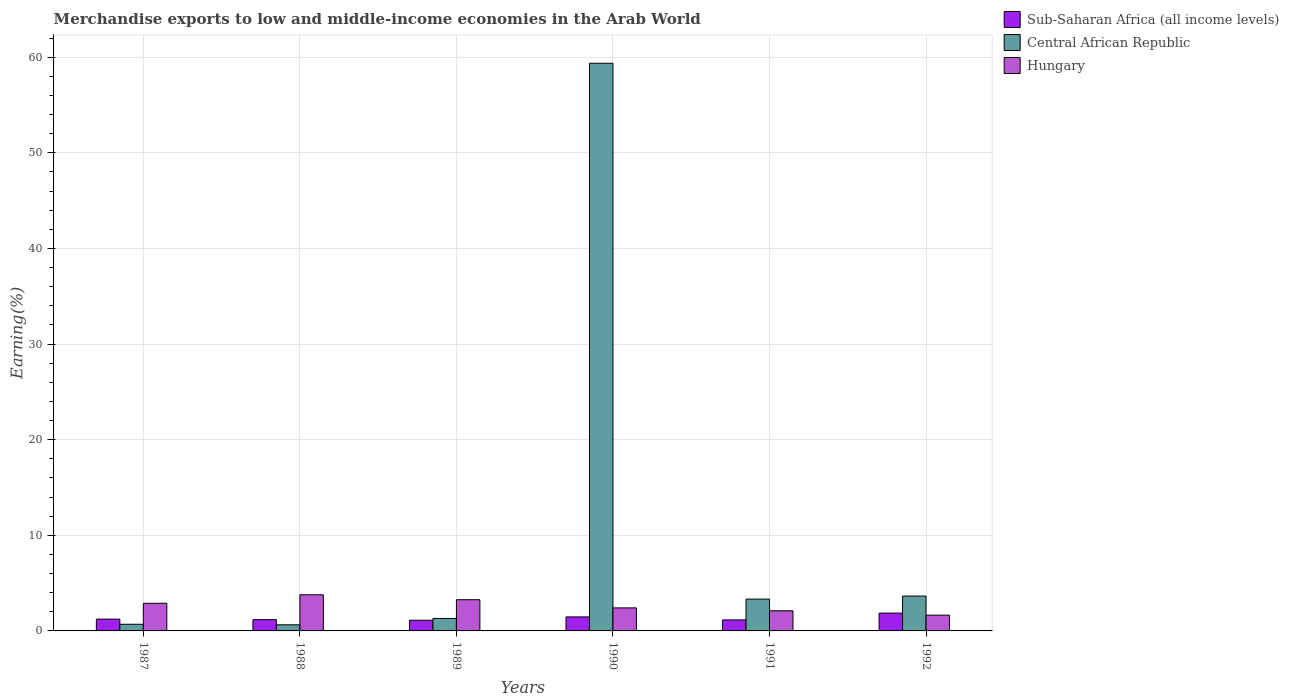How many different coloured bars are there?
Offer a terse response. 3. How many groups of bars are there?
Offer a very short reply. 6. How many bars are there on the 4th tick from the left?
Keep it short and to the point. 3. What is the percentage of amount earned from merchandise exports in Hungary in 1988?
Give a very brief answer. 3.78. Across all years, what is the maximum percentage of amount earned from merchandise exports in Central African Republic?
Your answer should be compact. 59.37. Across all years, what is the minimum percentage of amount earned from merchandise exports in Hungary?
Offer a very short reply. 1.65. In which year was the percentage of amount earned from merchandise exports in Hungary maximum?
Offer a terse response. 1988. What is the total percentage of amount earned from merchandise exports in Hungary in the graph?
Provide a succinct answer. 16.1. What is the difference between the percentage of amount earned from merchandise exports in Central African Republic in 1991 and that in 1992?
Your response must be concise. -0.32. What is the difference between the percentage of amount earned from merchandise exports in Central African Republic in 1989 and the percentage of amount earned from merchandise exports in Sub-Saharan Africa (all income levels) in 1990?
Offer a terse response. -0.16. What is the average percentage of amount earned from merchandise exports in Hungary per year?
Make the answer very short. 2.68. In the year 1988, what is the difference between the percentage of amount earned from merchandise exports in Hungary and percentage of amount earned from merchandise exports in Sub-Saharan Africa (all income levels)?
Make the answer very short. 2.6. In how many years, is the percentage of amount earned from merchandise exports in Sub-Saharan Africa (all income levels) greater than 24 %?
Provide a succinct answer. 0. What is the ratio of the percentage of amount earned from merchandise exports in Central African Republic in 1987 to that in 1988?
Your response must be concise. 1.09. Is the percentage of amount earned from merchandise exports in Sub-Saharan Africa (all income levels) in 1987 less than that in 1988?
Your response must be concise. No. Is the difference between the percentage of amount earned from merchandise exports in Hungary in 1989 and 1990 greater than the difference between the percentage of amount earned from merchandise exports in Sub-Saharan Africa (all income levels) in 1989 and 1990?
Offer a terse response. Yes. What is the difference between the highest and the second highest percentage of amount earned from merchandise exports in Sub-Saharan Africa (all income levels)?
Offer a very short reply. 0.4. What is the difference between the highest and the lowest percentage of amount earned from merchandise exports in Sub-Saharan Africa (all income levels)?
Your response must be concise. 0.75. What does the 2nd bar from the left in 1990 represents?
Your response must be concise. Central African Republic. What does the 3rd bar from the right in 1990 represents?
Your answer should be compact. Sub-Saharan Africa (all income levels). Is it the case that in every year, the sum of the percentage of amount earned from merchandise exports in Sub-Saharan Africa (all income levels) and percentage of amount earned from merchandise exports in Hungary is greater than the percentage of amount earned from merchandise exports in Central African Republic?
Ensure brevity in your answer.  No. How many bars are there?
Your answer should be very brief. 18. Are all the bars in the graph horizontal?
Keep it short and to the point. No. Are the values on the major ticks of Y-axis written in scientific E-notation?
Offer a terse response. No. Does the graph contain any zero values?
Your answer should be compact. No. How are the legend labels stacked?
Give a very brief answer. Vertical. What is the title of the graph?
Your answer should be compact. Merchandise exports to low and middle-income economies in the Arab World. What is the label or title of the Y-axis?
Offer a terse response. Earning(%). What is the Earning(%) in Sub-Saharan Africa (all income levels) in 1987?
Your answer should be very brief. 1.24. What is the Earning(%) of Central African Republic in 1987?
Your answer should be compact. 0.7. What is the Earning(%) in Hungary in 1987?
Make the answer very short. 2.89. What is the Earning(%) of Sub-Saharan Africa (all income levels) in 1988?
Offer a very short reply. 1.18. What is the Earning(%) of Central African Republic in 1988?
Offer a very short reply. 0.64. What is the Earning(%) of Hungary in 1988?
Make the answer very short. 3.78. What is the Earning(%) in Sub-Saharan Africa (all income levels) in 1989?
Keep it short and to the point. 1.12. What is the Earning(%) of Central African Republic in 1989?
Provide a short and direct response. 1.3. What is the Earning(%) in Hungary in 1989?
Provide a succinct answer. 3.26. What is the Earning(%) of Sub-Saharan Africa (all income levels) in 1990?
Provide a short and direct response. 1.47. What is the Earning(%) in Central African Republic in 1990?
Provide a short and direct response. 59.37. What is the Earning(%) in Hungary in 1990?
Provide a short and direct response. 2.41. What is the Earning(%) in Sub-Saharan Africa (all income levels) in 1991?
Keep it short and to the point. 1.15. What is the Earning(%) in Central African Republic in 1991?
Your answer should be very brief. 3.33. What is the Earning(%) of Hungary in 1991?
Ensure brevity in your answer.  2.1. What is the Earning(%) in Sub-Saharan Africa (all income levels) in 1992?
Provide a succinct answer. 1.86. What is the Earning(%) in Central African Republic in 1992?
Your answer should be very brief. 3.65. What is the Earning(%) of Hungary in 1992?
Offer a terse response. 1.65. Across all years, what is the maximum Earning(%) in Sub-Saharan Africa (all income levels)?
Offer a terse response. 1.86. Across all years, what is the maximum Earning(%) in Central African Republic?
Ensure brevity in your answer.  59.37. Across all years, what is the maximum Earning(%) in Hungary?
Offer a terse response. 3.78. Across all years, what is the minimum Earning(%) in Sub-Saharan Africa (all income levels)?
Provide a succinct answer. 1.12. Across all years, what is the minimum Earning(%) in Central African Republic?
Keep it short and to the point. 0.64. Across all years, what is the minimum Earning(%) in Hungary?
Give a very brief answer. 1.65. What is the total Earning(%) of Sub-Saharan Africa (all income levels) in the graph?
Offer a terse response. 8.01. What is the total Earning(%) in Central African Republic in the graph?
Make the answer very short. 68.98. What is the total Earning(%) in Hungary in the graph?
Provide a short and direct response. 16.1. What is the difference between the Earning(%) of Sub-Saharan Africa (all income levels) in 1987 and that in 1988?
Give a very brief answer. 0.05. What is the difference between the Earning(%) in Central African Republic in 1987 and that in 1988?
Your answer should be very brief. 0.06. What is the difference between the Earning(%) of Hungary in 1987 and that in 1988?
Provide a succinct answer. -0.89. What is the difference between the Earning(%) of Sub-Saharan Africa (all income levels) in 1987 and that in 1989?
Keep it short and to the point. 0.12. What is the difference between the Earning(%) of Central African Republic in 1987 and that in 1989?
Your answer should be compact. -0.61. What is the difference between the Earning(%) in Hungary in 1987 and that in 1989?
Your response must be concise. -0.37. What is the difference between the Earning(%) of Sub-Saharan Africa (all income levels) in 1987 and that in 1990?
Your response must be concise. -0.23. What is the difference between the Earning(%) of Central African Republic in 1987 and that in 1990?
Make the answer very short. -58.67. What is the difference between the Earning(%) in Hungary in 1987 and that in 1990?
Your response must be concise. 0.48. What is the difference between the Earning(%) in Sub-Saharan Africa (all income levels) in 1987 and that in 1991?
Ensure brevity in your answer.  0.08. What is the difference between the Earning(%) in Central African Republic in 1987 and that in 1991?
Your answer should be compact. -2.63. What is the difference between the Earning(%) of Hungary in 1987 and that in 1991?
Provide a succinct answer. 0.79. What is the difference between the Earning(%) in Sub-Saharan Africa (all income levels) in 1987 and that in 1992?
Ensure brevity in your answer.  -0.63. What is the difference between the Earning(%) of Central African Republic in 1987 and that in 1992?
Your answer should be compact. -2.95. What is the difference between the Earning(%) in Hungary in 1987 and that in 1992?
Your answer should be very brief. 1.25. What is the difference between the Earning(%) in Sub-Saharan Africa (all income levels) in 1988 and that in 1989?
Give a very brief answer. 0.06. What is the difference between the Earning(%) of Central African Republic in 1988 and that in 1989?
Keep it short and to the point. -0.66. What is the difference between the Earning(%) in Hungary in 1988 and that in 1989?
Keep it short and to the point. 0.52. What is the difference between the Earning(%) in Sub-Saharan Africa (all income levels) in 1988 and that in 1990?
Your response must be concise. -0.28. What is the difference between the Earning(%) in Central African Republic in 1988 and that in 1990?
Ensure brevity in your answer.  -58.73. What is the difference between the Earning(%) in Hungary in 1988 and that in 1990?
Provide a succinct answer. 1.37. What is the difference between the Earning(%) of Sub-Saharan Africa (all income levels) in 1988 and that in 1991?
Your response must be concise. 0.03. What is the difference between the Earning(%) of Central African Republic in 1988 and that in 1991?
Your answer should be very brief. -2.69. What is the difference between the Earning(%) of Hungary in 1988 and that in 1991?
Provide a short and direct response. 1.68. What is the difference between the Earning(%) of Sub-Saharan Africa (all income levels) in 1988 and that in 1992?
Your answer should be compact. -0.68. What is the difference between the Earning(%) in Central African Republic in 1988 and that in 1992?
Make the answer very short. -3.01. What is the difference between the Earning(%) of Hungary in 1988 and that in 1992?
Give a very brief answer. 2.13. What is the difference between the Earning(%) in Sub-Saharan Africa (all income levels) in 1989 and that in 1990?
Offer a very short reply. -0.35. What is the difference between the Earning(%) of Central African Republic in 1989 and that in 1990?
Your answer should be very brief. -58.07. What is the difference between the Earning(%) in Hungary in 1989 and that in 1990?
Your answer should be very brief. 0.85. What is the difference between the Earning(%) of Sub-Saharan Africa (all income levels) in 1989 and that in 1991?
Offer a very short reply. -0.03. What is the difference between the Earning(%) of Central African Republic in 1989 and that in 1991?
Offer a very short reply. -2.02. What is the difference between the Earning(%) of Hungary in 1989 and that in 1991?
Offer a terse response. 1.16. What is the difference between the Earning(%) of Sub-Saharan Africa (all income levels) in 1989 and that in 1992?
Keep it short and to the point. -0.74. What is the difference between the Earning(%) of Central African Republic in 1989 and that in 1992?
Your answer should be very brief. -2.34. What is the difference between the Earning(%) of Hungary in 1989 and that in 1992?
Provide a short and direct response. 1.62. What is the difference between the Earning(%) in Sub-Saharan Africa (all income levels) in 1990 and that in 1991?
Provide a succinct answer. 0.31. What is the difference between the Earning(%) in Central African Republic in 1990 and that in 1991?
Offer a very short reply. 56.04. What is the difference between the Earning(%) of Hungary in 1990 and that in 1991?
Offer a terse response. 0.31. What is the difference between the Earning(%) of Sub-Saharan Africa (all income levels) in 1990 and that in 1992?
Give a very brief answer. -0.4. What is the difference between the Earning(%) in Central African Republic in 1990 and that in 1992?
Offer a terse response. 55.72. What is the difference between the Earning(%) in Hungary in 1990 and that in 1992?
Offer a very short reply. 0.76. What is the difference between the Earning(%) of Sub-Saharan Africa (all income levels) in 1991 and that in 1992?
Offer a very short reply. -0.71. What is the difference between the Earning(%) of Central African Republic in 1991 and that in 1992?
Keep it short and to the point. -0.32. What is the difference between the Earning(%) of Hungary in 1991 and that in 1992?
Your answer should be very brief. 0.46. What is the difference between the Earning(%) of Sub-Saharan Africa (all income levels) in 1987 and the Earning(%) of Central African Republic in 1988?
Keep it short and to the point. 0.6. What is the difference between the Earning(%) in Sub-Saharan Africa (all income levels) in 1987 and the Earning(%) in Hungary in 1988?
Offer a very short reply. -2.55. What is the difference between the Earning(%) in Central African Republic in 1987 and the Earning(%) in Hungary in 1988?
Keep it short and to the point. -3.09. What is the difference between the Earning(%) in Sub-Saharan Africa (all income levels) in 1987 and the Earning(%) in Central African Republic in 1989?
Provide a short and direct response. -0.07. What is the difference between the Earning(%) in Sub-Saharan Africa (all income levels) in 1987 and the Earning(%) in Hungary in 1989?
Make the answer very short. -2.03. What is the difference between the Earning(%) in Central African Republic in 1987 and the Earning(%) in Hungary in 1989?
Your response must be concise. -2.57. What is the difference between the Earning(%) in Sub-Saharan Africa (all income levels) in 1987 and the Earning(%) in Central African Republic in 1990?
Ensure brevity in your answer.  -58.14. What is the difference between the Earning(%) of Sub-Saharan Africa (all income levels) in 1987 and the Earning(%) of Hungary in 1990?
Keep it short and to the point. -1.18. What is the difference between the Earning(%) in Central African Republic in 1987 and the Earning(%) in Hungary in 1990?
Your answer should be compact. -1.71. What is the difference between the Earning(%) of Sub-Saharan Africa (all income levels) in 1987 and the Earning(%) of Central African Republic in 1991?
Offer a very short reply. -2.09. What is the difference between the Earning(%) of Sub-Saharan Africa (all income levels) in 1987 and the Earning(%) of Hungary in 1991?
Your answer should be very brief. -0.87. What is the difference between the Earning(%) of Central African Republic in 1987 and the Earning(%) of Hungary in 1991?
Ensure brevity in your answer.  -1.41. What is the difference between the Earning(%) of Sub-Saharan Africa (all income levels) in 1987 and the Earning(%) of Central African Republic in 1992?
Your answer should be very brief. -2.41. What is the difference between the Earning(%) in Sub-Saharan Africa (all income levels) in 1987 and the Earning(%) in Hungary in 1992?
Ensure brevity in your answer.  -0.41. What is the difference between the Earning(%) of Central African Republic in 1987 and the Earning(%) of Hungary in 1992?
Your answer should be very brief. -0.95. What is the difference between the Earning(%) of Sub-Saharan Africa (all income levels) in 1988 and the Earning(%) of Central African Republic in 1989?
Offer a terse response. -0.12. What is the difference between the Earning(%) of Sub-Saharan Africa (all income levels) in 1988 and the Earning(%) of Hungary in 1989?
Give a very brief answer. -2.08. What is the difference between the Earning(%) in Central African Republic in 1988 and the Earning(%) in Hungary in 1989?
Keep it short and to the point. -2.63. What is the difference between the Earning(%) of Sub-Saharan Africa (all income levels) in 1988 and the Earning(%) of Central African Republic in 1990?
Your response must be concise. -58.19. What is the difference between the Earning(%) of Sub-Saharan Africa (all income levels) in 1988 and the Earning(%) of Hungary in 1990?
Make the answer very short. -1.23. What is the difference between the Earning(%) in Central African Republic in 1988 and the Earning(%) in Hungary in 1990?
Ensure brevity in your answer.  -1.77. What is the difference between the Earning(%) in Sub-Saharan Africa (all income levels) in 1988 and the Earning(%) in Central African Republic in 1991?
Offer a very short reply. -2.15. What is the difference between the Earning(%) of Sub-Saharan Africa (all income levels) in 1988 and the Earning(%) of Hungary in 1991?
Offer a terse response. -0.92. What is the difference between the Earning(%) in Central African Republic in 1988 and the Earning(%) in Hungary in 1991?
Make the answer very short. -1.47. What is the difference between the Earning(%) in Sub-Saharan Africa (all income levels) in 1988 and the Earning(%) in Central African Republic in 1992?
Offer a very short reply. -2.47. What is the difference between the Earning(%) of Sub-Saharan Africa (all income levels) in 1988 and the Earning(%) of Hungary in 1992?
Your answer should be compact. -0.47. What is the difference between the Earning(%) in Central African Republic in 1988 and the Earning(%) in Hungary in 1992?
Ensure brevity in your answer.  -1.01. What is the difference between the Earning(%) in Sub-Saharan Africa (all income levels) in 1989 and the Earning(%) in Central African Republic in 1990?
Your answer should be very brief. -58.25. What is the difference between the Earning(%) of Sub-Saharan Africa (all income levels) in 1989 and the Earning(%) of Hungary in 1990?
Ensure brevity in your answer.  -1.29. What is the difference between the Earning(%) of Central African Republic in 1989 and the Earning(%) of Hungary in 1990?
Provide a short and direct response. -1.11. What is the difference between the Earning(%) of Sub-Saharan Africa (all income levels) in 1989 and the Earning(%) of Central African Republic in 1991?
Ensure brevity in your answer.  -2.21. What is the difference between the Earning(%) in Sub-Saharan Africa (all income levels) in 1989 and the Earning(%) in Hungary in 1991?
Offer a very short reply. -0.99. What is the difference between the Earning(%) in Central African Republic in 1989 and the Earning(%) in Hungary in 1991?
Provide a succinct answer. -0.8. What is the difference between the Earning(%) of Sub-Saharan Africa (all income levels) in 1989 and the Earning(%) of Central African Republic in 1992?
Offer a terse response. -2.53. What is the difference between the Earning(%) in Sub-Saharan Africa (all income levels) in 1989 and the Earning(%) in Hungary in 1992?
Make the answer very short. -0.53. What is the difference between the Earning(%) of Central African Republic in 1989 and the Earning(%) of Hungary in 1992?
Offer a terse response. -0.34. What is the difference between the Earning(%) of Sub-Saharan Africa (all income levels) in 1990 and the Earning(%) of Central African Republic in 1991?
Your response must be concise. -1.86. What is the difference between the Earning(%) of Sub-Saharan Africa (all income levels) in 1990 and the Earning(%) of Hungary in 1991?
Offer a very short reply. -0.64. What is the difference between the Earning(%) of Central African Republic in 1990 and the Earning(%) of Hungary in 1991?
Your response must be concise. 57.27. What is the difference between the Earning(%) in Sub-Saharan Africa (all income levels) in 1990 and the Earning(%) in Central African Republic in 1992?
Your answer should be very brief. -2.18. What is the difference between the Earning(%) in Sub-Saharan Africa (all income levels) in 1990 and the Earning(%) in Hungary in 1992?
Provide a short and direct response. -0.18. What is the difference between the Earning(%) in Central African Republic in 1990 and the Earning(%) in Hungary in 1992?
Your answer should be compact. 57.72. What is the difference between the Earning(%) of Sub-Saharan Africa (all income levels) in 1991 and the Earning(%) of Central African Republic in 1992?
Offer a terse response. -2.5. What is the difference between the Earning(%) of Sub-Saharan Africa (all income levels) in 1991 and the Earning(%) of Hungary in 1992?
Give a very brief answer. -0.5. What is the difference between the Earning(%) of Central African Republic in 1991 and the Earning(%) of Hungary in 1992?
Provide a short and direct response. 1.68. What is the average Earning(%) in Sub-Saharan Africa (all income levels) per year?
Make the answer very short. 1.34. What is the average Earning(%) of Central African Republic per year?
Offer a terse response. 11.5. What is the average Earning(%) in Hungary per year?
Offer a very short reply. 2.68. In the year 1987, what is the difference between the Earning(%) of Sub-Saharan Africa (all income levels) and Earning(%) of Central African Republic?
Give a very brief answer. 0.54. In the year 1987, what is the difference between the Earning(%) in Sub-Saharan Africa (all income levels) and Earning(%) in Hungary?
Give a very brief answer. -1.66. In the year 1987, what is the difference between the Earning(%) in Central African Republic and Earning(%) in Hungary?
Keep it short and to the point. -2.2. In the year 1988, what is the difference between the Earning(%) of Sub-Saharan Africa (all income levels) and Earning(%) of Central African Republic?
Your answer should be compact. 0.54. In the year 1988, what is the difference between the Earning(%) in Sub-Saharan Africa (all income levels) and Earning(%) in Hungary?
Your answer should be very brief. -2.6. In the year 1988, what is the difference between the Earning(%) of Central African Republic and Earning(%) of Hungary?
Give a very brief answer. -3.14. In the year 1989, what is the difference between the Earning(%) of Sub-Saharan Africa (all income levels) and Earning(%) of Central African Republic?
Your answer should be very brief. -0.19. In the year 1989, what is the difference between the Earning(%) in Sub-Saharan Africa (all income levels) and Earning(%) in Hungary?
Your answer should be compact. -2.15. In the year 1989, what is the difference between the Earning(%) of Central African Republic and Earning(%) of Hungary?
Keep it short and to the point. -1.96. In the year 1990, what is the difference between the Earning(%) in Sub-Saharan Africa (all income levels) and Earning(%) in Central African Republic?
Make the answer very short. -57.91. In the year 1990, what is the difference between the Earning(%) of Sub-Saharan Africa (all income levels) and Earning(%) of Hungary?
Offer a very short reply. -0.94. In the year 1990, what is the difference between the Earning(%) of Central African Republic and Earning(%) of Hungary?
Your response must be concise. 56.96. In the year 1991, what is the difference between the Earning(%) of Sub-Saharan Africa (all income levels) and Earning(%) of Central African Republic?
Provide a short and direct response. -2.18. In the year 1991, what is the difference between the Earning(%) in Sub-Saharan Africa (all income levels) and Earning(%) in Hungary?
Give a very brief answer. -0.95. In the year 1991, what is the difference between the Earning(%) in Central African Republic and Earning(%) in Hungary?
Offer a very short reply. 1.22. In the year 1992, what is the difference between the Earning(%) of Sub-Saharan Africa (all income levels) and Earning(%) of Central African Republic?
Provide a succinct answer. -1.78. In the year 1992, what is the difference between the Earning(%) of Sub-Saharan Africa (all income levels) and Earning(%) of Hungary?
Provide a succinct answer. 0.21. In the year 1992, what is the difference between the Earning(%) in Central African Republic and Earning(%) in Hungary?
Offer a terse response. 2. What is the ratio of the Earning(%) in Sub-Saharan Africa (all income levels) in 1987 to that in 1988?
Offer a very short reply. 1.05. What is the ratio of the Earning(%) of Central African Republic in 1987 to that in 1988?
Ensure brevity in your answer.  1.09. What is the ratio of the Earning(%) of Hungary in 1987 to that in 1988?
Keep it short and to the point. 0.77. What is the ratio of the Earning(%) in Sub-Saharan Africa (all income levels) in 1987 to that in 1989?
Make the answer very short. 1.11. What is the ratio of the Earning(%) of Central African Republic in 1987 to that in 1989?
Provide a short and direct response. 0.53. What is the ratio of the Earning(%) of Hungary in 1987 to that in 1989?
Your answer should be very brief. 0.89. What is the ratio of the Earning(%) of Sub-Saharan Africa (all income levels) in 1987 to that in 1990?
Give a very brief answer. 0.84. What is the ratio of the Earning(%) in Central African Republic in 1987 to that in 1990?
Make the answer very short. 0.01. What is the ratio of the Earning(%) of Hungary in 1987 to that in 1990?
Provide a short and direct response. 1.2. What is the ratio of the Earning(%) of Sub-Saharan Africa (all income levels) in 1987 to that in 1991?
Ensure brevity in your answer.  1.07. What is the ratio of the Earning(%) in Central African Republic in 1987 to that in 1991?
Keep it short and to the point. 0.21. What is the ratio of the Earning(%) of Hungary in 1987 to that in 1991?
Your answer should be very brief. 1.37. What is the ratio of the Earning(%) in Sub-Saharan Africa (all income levels) in 1987 to that in 1992?
Make the answer very short. 0.66. What is the ratio of the Earning(%) in Central African Republic in 1987 to that in 1992?
Keep it short and to the point. 0.19. What is the ratio of the Earning(%) of Hungary in 1987 to that in 1992?
Your answer should be very brief. 1.76. What is the ratio of the Earning(%) in Sub-Saharan Africa (all income levels) in 1988 to that in 1989?
Ensure brevity in your answer.  1.06. What is the ratio of the Earning(%) of Central African Republic in 1988 to that in 1989?
Give a very brief answer. 0.49. What is the ratio of the Earning(%) of Hungary in 1988 to that in 1989?
Ensure brevity in your answer.  1.16. What is the ratio of the Earning(%) in Sub-Saharan Africa (all income levels) in 1988 to that in 1990?
Provide a succinct answer. 0.81. What is the ratio of the Earning(%) of Central African Republic in 1988 to that in 1990?
Offer a very short reply. 0.01. What is the ratio of the Earning(%) of Hungary in 1988 to that in 1990?
Your answer should be very brief. 1.57. What is the ratio of the Earning(%) in Sub-Saharan Africa (all income levels) in 1988 to that in 1991?
Give a very brief answer. 1.03. What is the ratio of the Earning(%) of Central African Republic in 1988 to that in 1991?
Ensure brevity in your answer.  0.19. What is the ratio of the Earning(%) of Hungary in 1988 to that in 1991?
Your answer should be compact. 1.8. What is the ratio of the Earning(%) of Sub-Saharan Africa (all income levels) in 1988 to that in 1992?
Your answer should be compact. 0.63. What is the ratio of the Earning(%) of Central African Republic in 1988 to that in 1992?
Your answer should be compact. 0.18. What is the ratio of the Earning(%) of Hungary in 1988 to that in 1992?
Your response must be concise. 2.29. What is the ratio of the Earning(%) in Sub-Saharan Africa (all income levels) in 1989 to that in 1990?
Your answer should be very brief. 0.76. What is the ratio of the Earning(%) of Central African Republic in 1989 to that in 1990?
Provide a short and direct response. 0.02. What is the ratio of the Earning(%) of Hungary in 1989 to that in 1990?
Keep it short and to the point. 1.35. What is the ratio of the Earning(%) in Sub-Saharan Africa (all income levels) in 1989 to that in 1991?
Provide a succinct answer. 0.97. What is the ratio of the Earning(%) in Central African Republic in 1989 to that in 1991?
Offer a very short reply. 0.39. What is the ratio of the Earning(%) of Hungary in 1989 to that in 1991?
Offer a terse response. 1.55. What is the ratio of the Earning(%) of Sub-Saharan Africa (all income levels) in 1989 to that in 1992?
Offer a very short reply. 0.6. What is the ratio of the Earning(%) of Central African Republic in 1989 to that in 1992?
Offer a terse response. 0.36. What is the ratio of the Earning(%) of Hungary in 1989 to that in 1992?
Ensure brevity in your answer.  1.98. What is the ratio of the Earning(%) of Sub-Saharan Africa (all income levels) in 1990 to that in 1991?
Offer a terse response. 1.27. What is the ratio of the Earning(%) of Central African Republic in 1990 to that in 1991?
Provide a short and direct response. 17.84. What is the ratio of the Earning(%) of Hungary in 1990 to that in 1991?
Your response must be concise. 1.15. What is the ratio of the Earning(%) of Sub-Saharan Africa (all income levels) in 1990 to that in 1992?
Your answer should be compact. 0.79. What is the ratio of the Earning(%) of Central African Republic in 1990 to that in 1992?
Give a very brief answer. 16.28. What is the ratio of the Earning(%) in Hungary in 1990 to that in 1992?
Offer a terse response. 1.46. What is the ratio of the Earning(%) of Sub-Saharan Africa (all income levels) in 1991 to that in 1992?
Offer a very short reply. 0.62. What is the ratio of the Earning(%) of Central African Republic in 1991 to that in 1992?
Make the answer very short. 0.91. What is the ratio of the Earning(%) of Hungary in 1991 to that in 1992?
Provide a short and direct response. 1.28. What is the difference between the highest and the second highest Earning(%) of Sub-Saharan Africa (all income levels)?
Offer a very short reply. 0.4. What is the difference between the highest and the second highest Earning(%) in Central African Republic?
Your response must be concise. 55.72. What is the difference between the highest and the second highest Earning(%) of Hungary?
Offer a very short reply. 0.52. What is the difference between the highest and the lowest Earning(%) in Sub-Saharan Africa (all income levels)?
Keep it short and to the point. 0.74. What is the difference between the highest and the lowest Earning(%) in Central African Republic?
Ensure brevity in your answer.  58.73. What is the difference between the highest and the lowest Earning(%) in Hungary?
Provide a short and direct response. 2.13. 